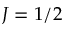Convert formula to latex. <formula><loc_0><loc_0><loc_500><loc_500>J = 1 / 2</formula> 